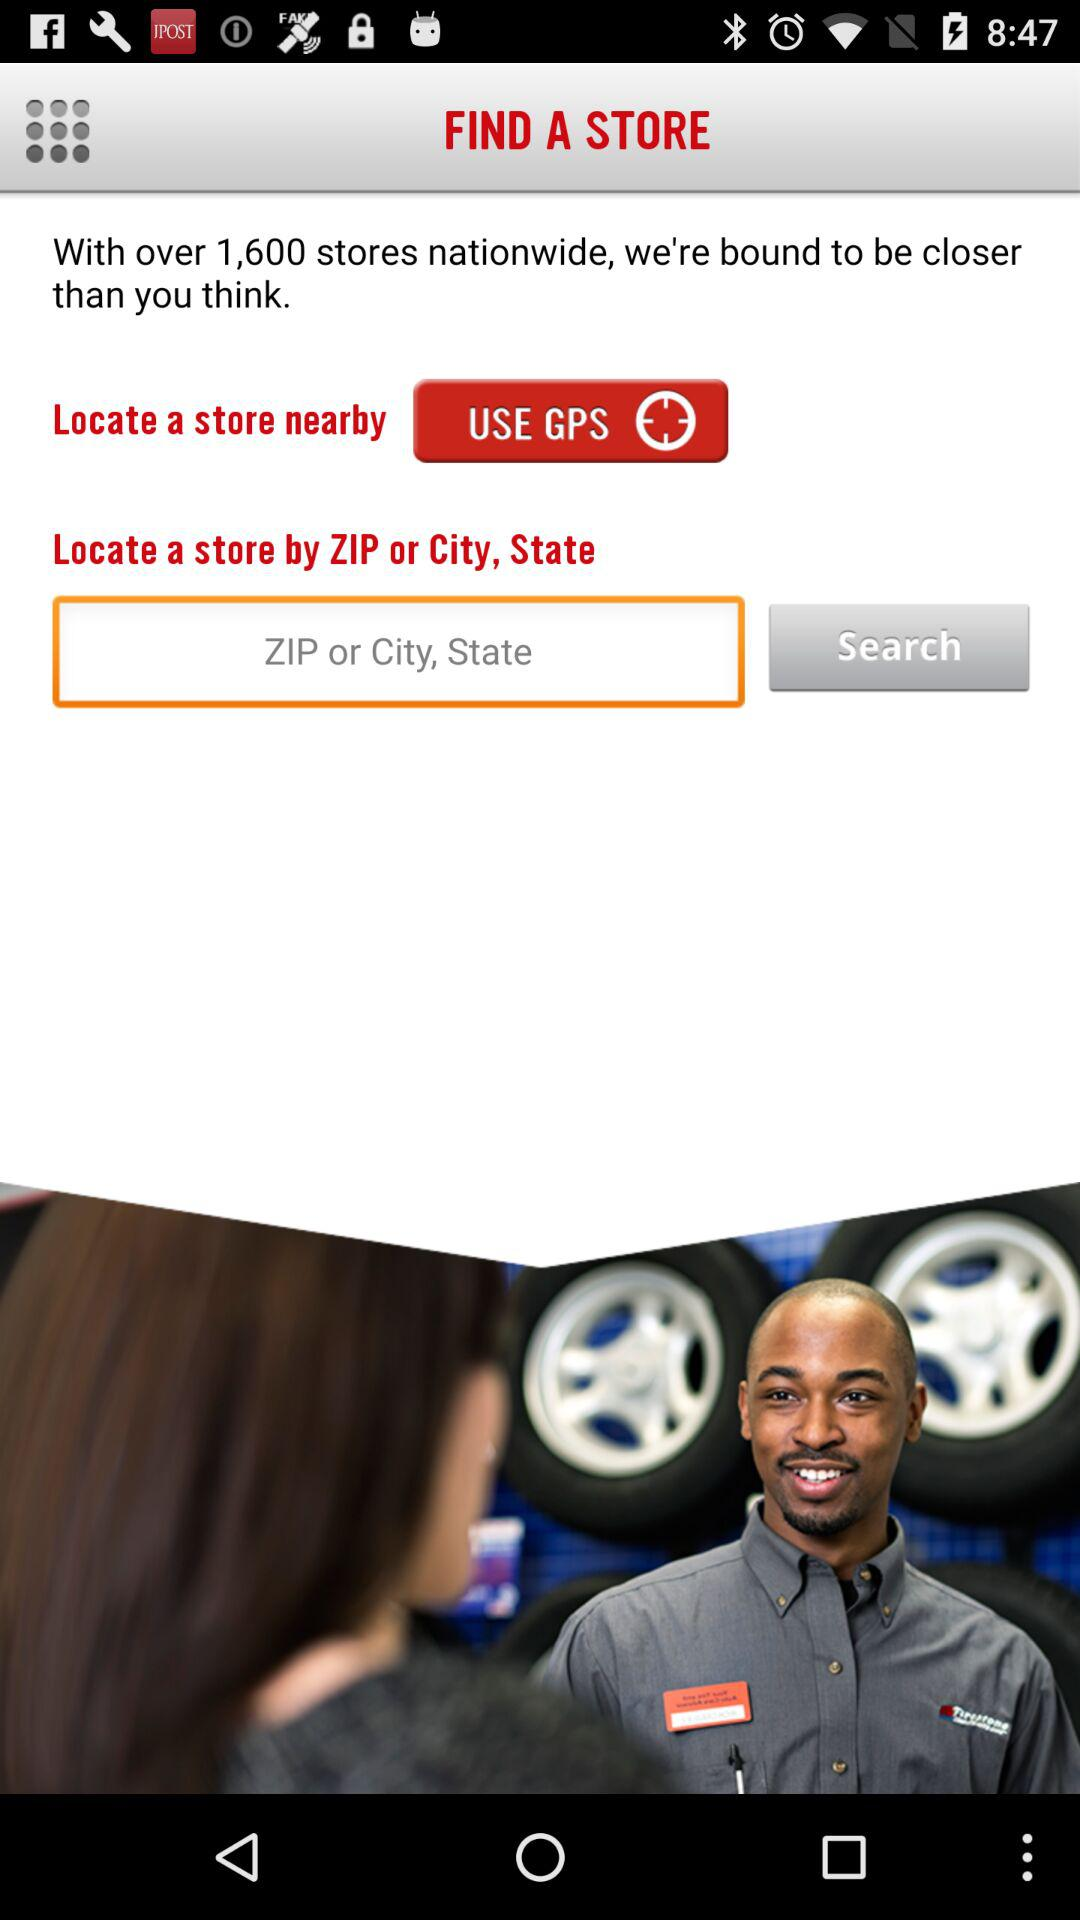How many stores are there nationwide? There are over 1,600 stores nationwide. 